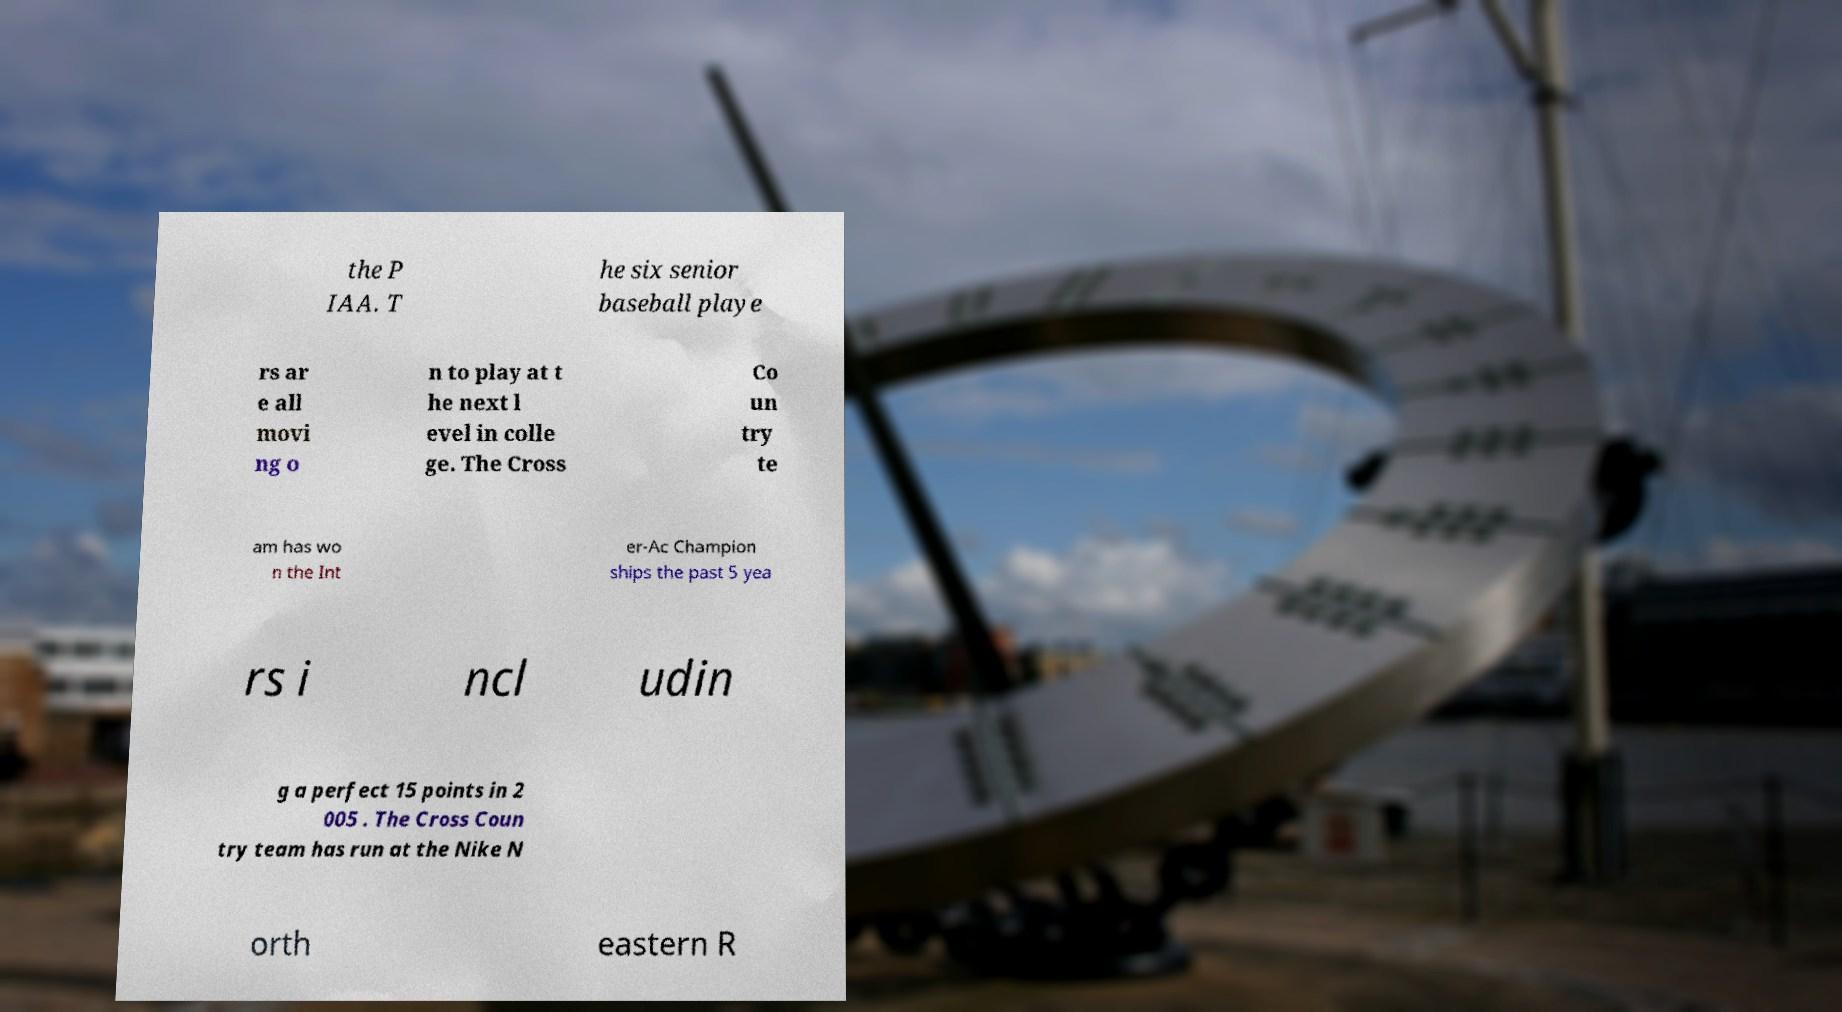Can you accurately transcribe the text from the provided image for me? the P IAA. T he six senior baseball playe rs ar e all movi ng o n to play at t he next l evel in colle ge. The Cross Co un try te am has wo n the Int er-Ac Champion ships the past 5 yea rs i ncl udin g a perfect 15 points in 2 005 . The Cross Coun try team has run at the Nike N orth eastern R 